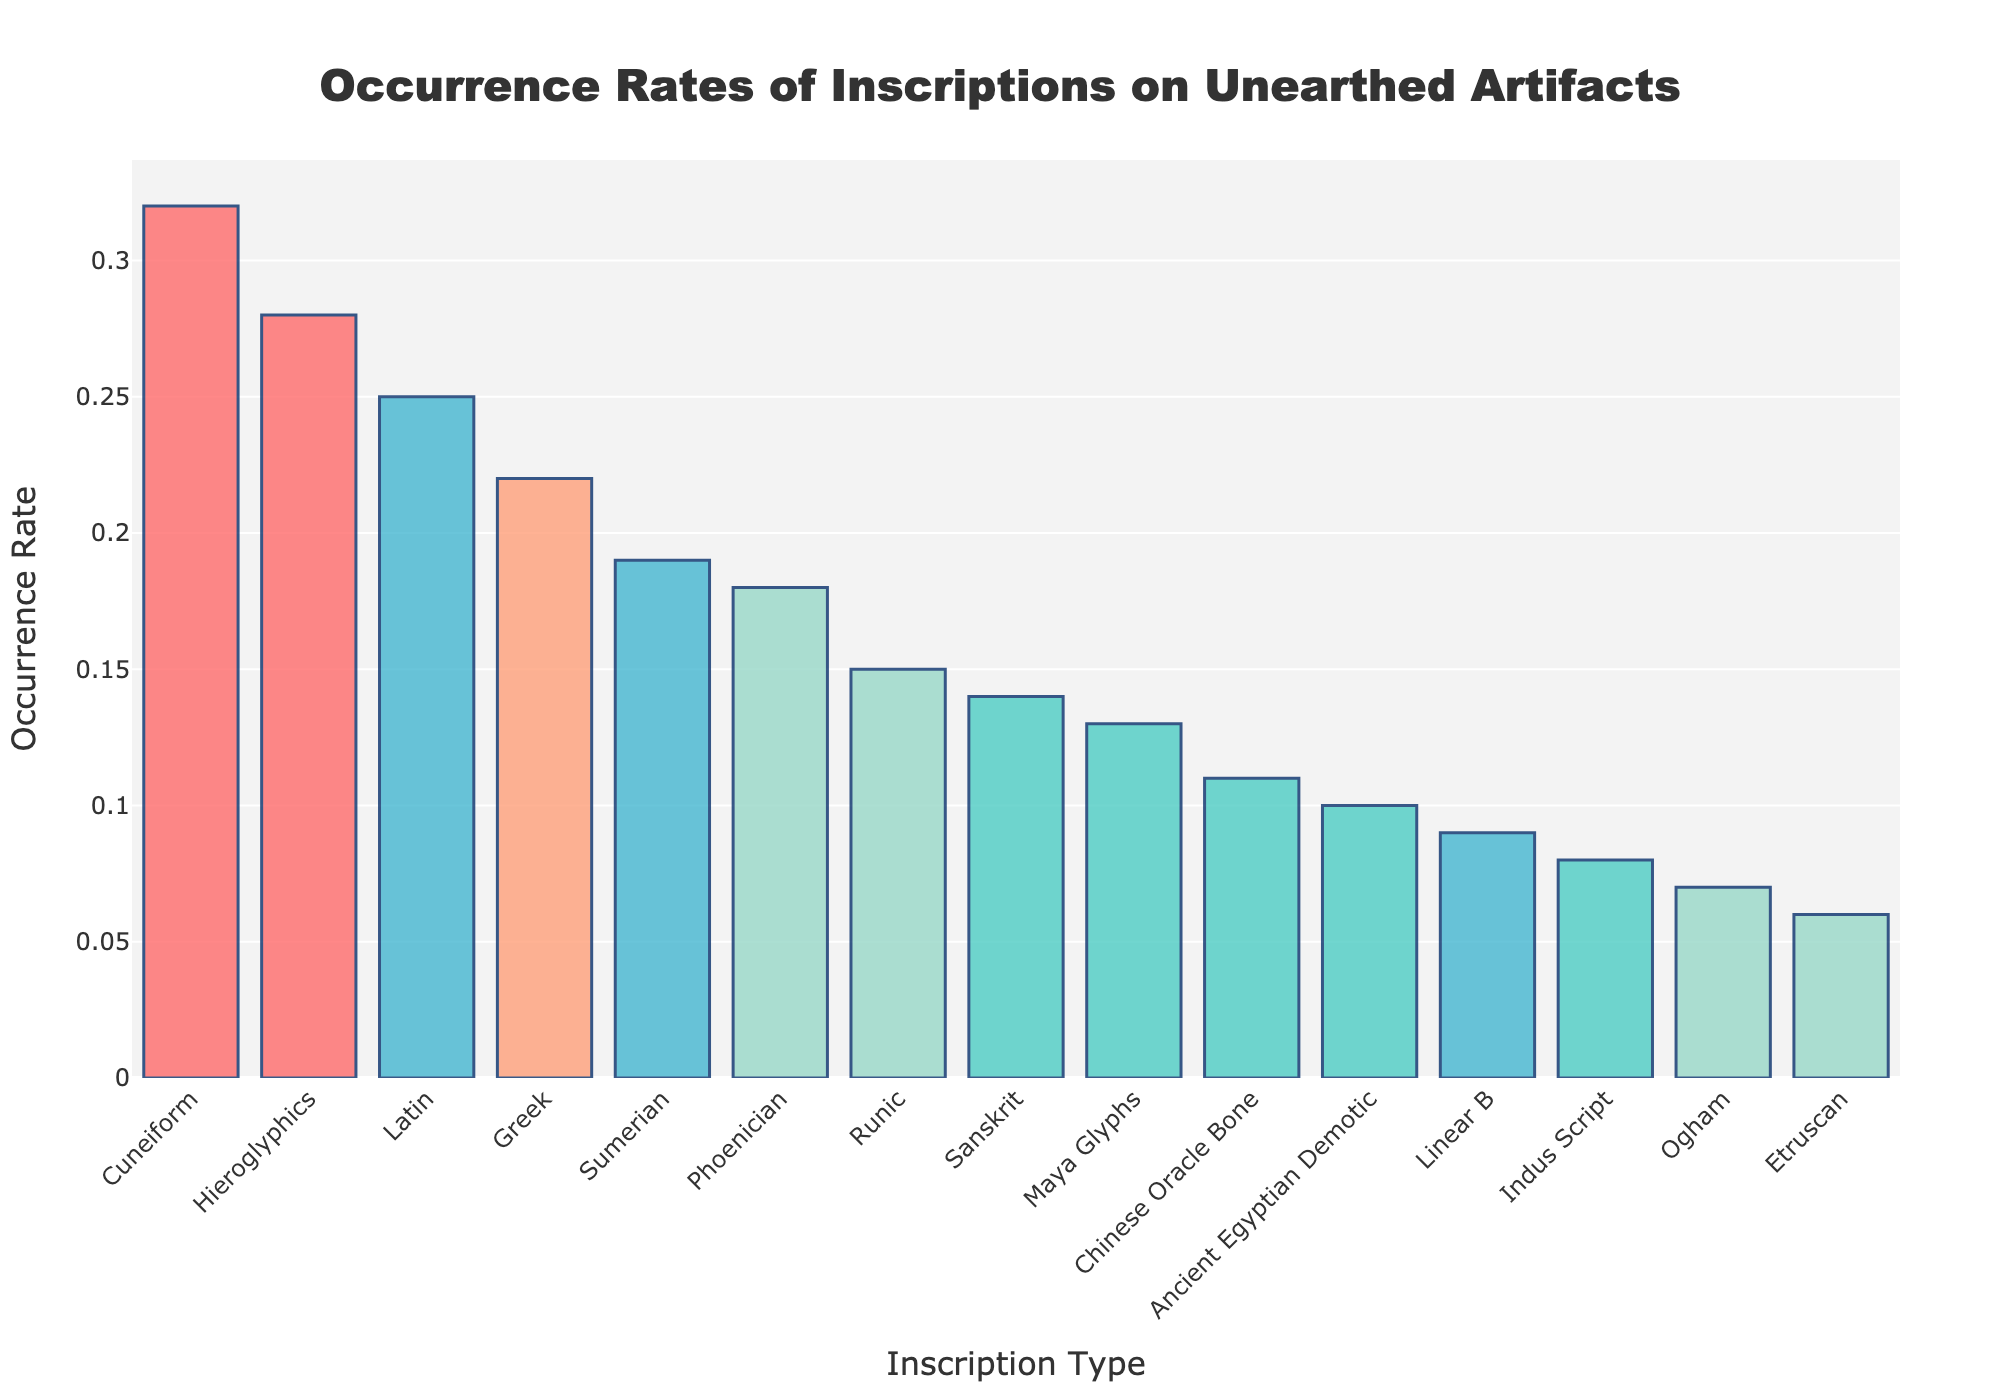what is the highest occurrence rate in the histogram? To find the highest occurrence rate, look at the bar that extends the highest along the y-axis. This bar represents the inscription "Cuneiform" with a rate of 0.32.
Answer: 0.32 Which inscription types have an occurrence rate of at least 0.2? To determine which inscription types have an occurrence rate of at least 0.2, identify the bars that extend to 0.2 or above on the y-axis. These inscriptions are Hieroglyphics, Latin, Greek, Phoenician, and Sumerian.
Answer: Hieroglyphics, Latin, Greek, Phoenician, Sumerian What is the difference in occurrence rate between the The highest and lowest occurrence rates? The highest occurrence rate is 0.32 (Cuneiform) and the lowest is 0.06 (Etruscan). Subtract the lowest from the highest to get the difference: 0.32 - 0.06 = 0.26.
Answer: 0.26 How many inscription types have an occurrence rate below 0.1? Count the number of bars that extend below the 0.1 mark on the y-axis. These bars represent Ogham, Indus Script, and Etruscan. There are three inscription types.
Answer: 3 Which inscription type has a greater occurrence rate: Greek or Latin? Compare the height of the bars for Greek and Latin. The Latin bar reaches 0.25, while the Greek bar reaches 0.22, so Latin has a greater occurrence rate.
Answer: Latin What is the average occurrence rate of the top three inscription types? Find the top three occurrence rates: Cuneiform (0.32), Hieroglyphics (0.28), and Latin (0.25). Calculate the average by summing these rates and dividing by three: (0.32 + 0.28 + 0.25) / 3 = 0.2833.
Answer: 0.28 Does the inscription type Chinese Oracle Bone have a higher occurrence rate than the average occurrence rate of all inscription types? First, determine the average occurrence rate of all types by summing all rates and dividing by the number of types. The sum is 2.67 and there are 15 types, so the average is 2.67 / 15 = 0.178. The occurrence rate for Chinese Oracle Bone is 0.11, which is lower than the average.
Answer: No What is the total occurrence rate for Runic, Linear B, and Ogham? Add the occurrence rates for Runic (0.15), Linear B (0.09), and Ogham (0.07) together: 0.15 + 0.09 + 0.07 = 0.31.
Answer: 0.31 Which inscription type has the second-lowest occurrence rate? Identify the bars from lowest to second-lowest. Etruscan has the lowest (0.06), and Ogham is the second-lowest with a rate of 0.07.
Answer: Ogham 